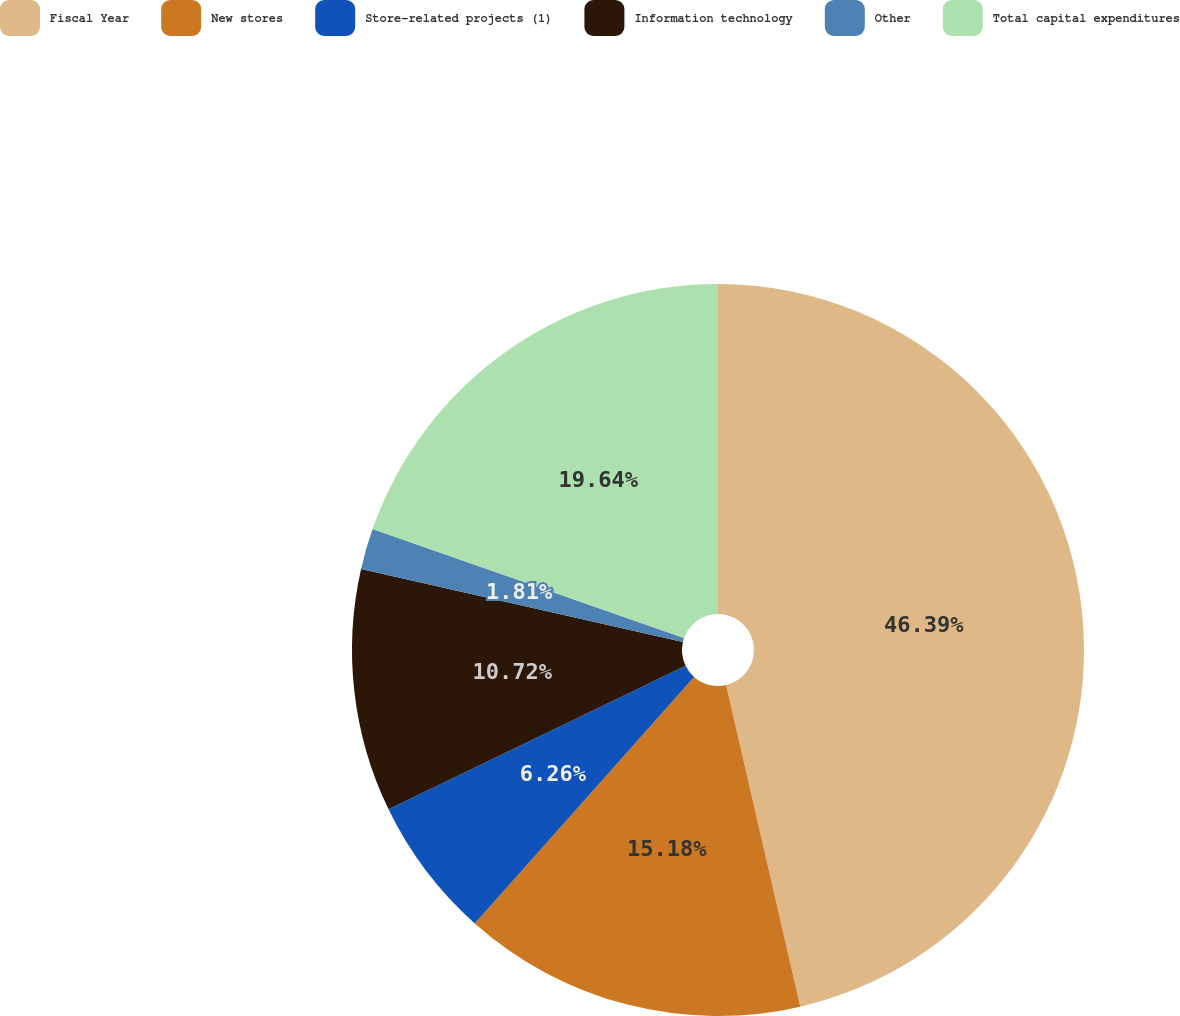Convert chart to OTSL. <chart><loc_0><loc_0><loc_500><loc_500><pie_chart><fcel>Fiscal Year<fcel>New stores<fcel>Store-related projects (1)<fcel>Information technology<fcel>Other<fcel>Total capital expenditures<nl><fcel>46.39%<fcel>15.18%<fcel>6.26%<fcel>10.72%<fcel>1.81%<fcel>19.64%<nl></chart> 